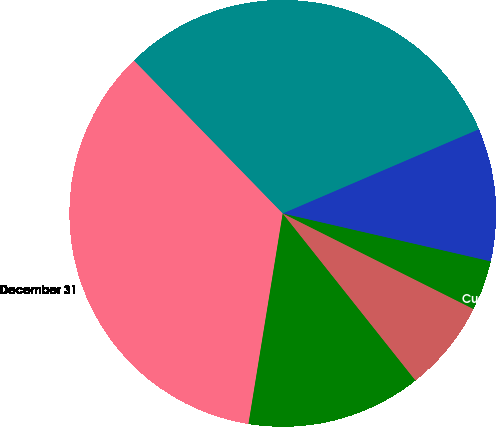Convert chart to OTSL. <chart><loc_0><loc_0><loc_500><loc_500><pie_chart><fcel>December 31<fcel>Deferred US federal income<fcel>Retirement benefits<fcel>Customer deposits on<fcel>Other<fcel>Total other liabilities<nl><fcel>35.15%<fcel>13.25%<fcel>6.92%<fcel>3.79%<fcel>10.06%<fcel>30.82%<nl></chart> 